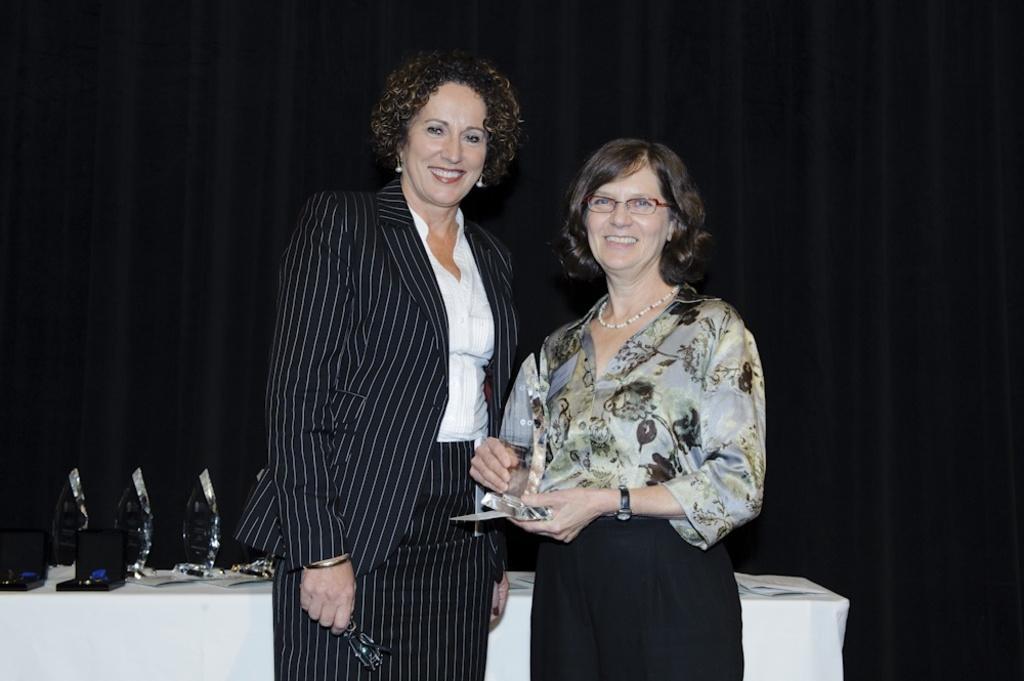Describe this image in one or two sentences. In this picture I can see couple of woman standing and I can see a woman holding spectacles in her hand and another woman holding a memento in her hand. I can see few memento´s on the table and looks like a curtain in the background. 